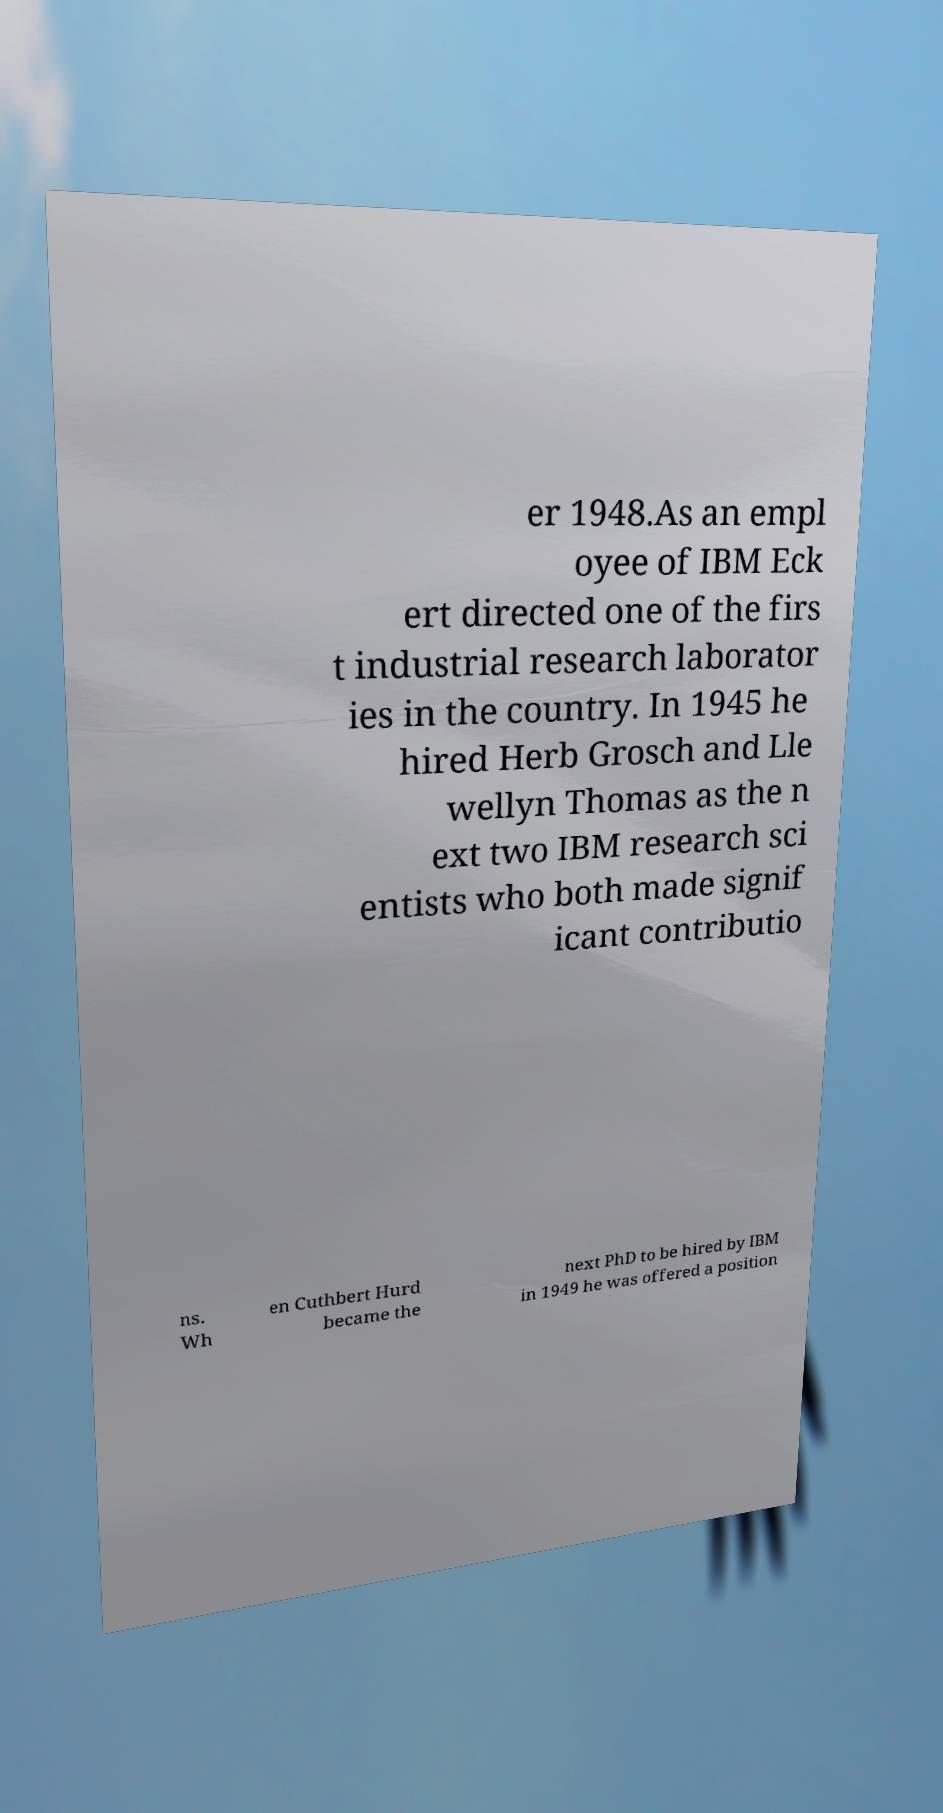Could you extract and type out the text from this image? er 1948.As an empl oyee of IBM Eck ert directed one of the firs t industrial research laborator ies in the country. In 1945 he hired Herb Grosch and Lle wellyn Thomas as the n ext two IBM research sci entists who both made signif icant contributio ns. Wh en Cuthbert Hurd became the next PhD to be hired by IBM in 1949 he was offered a position 